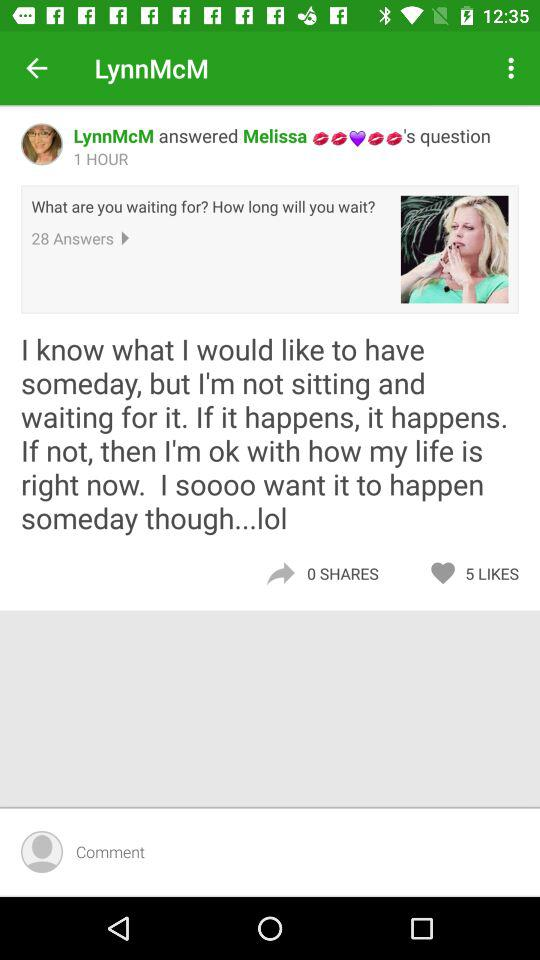How many likes does this post have?
Answer the question using a single word or phrase. 5 